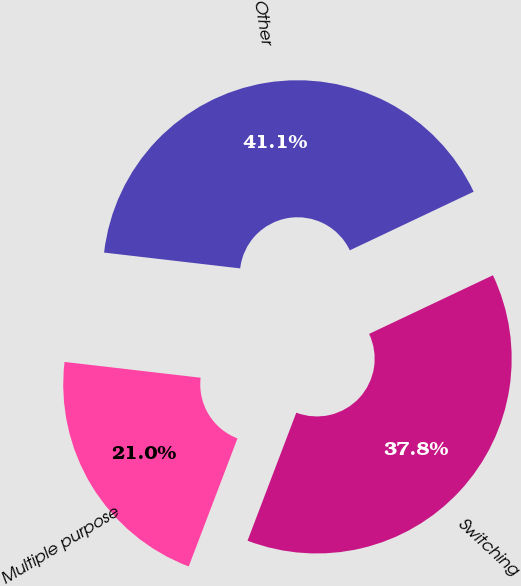<chart> <loc_0><loc_0><loc_500><loc_500><pie_chart><fcel>Multiple purpose<fcel>Switching<fcel>Other<nl><fcel>21.05%<fcel>37.83%<fcel>41.12%<nl></chart> 